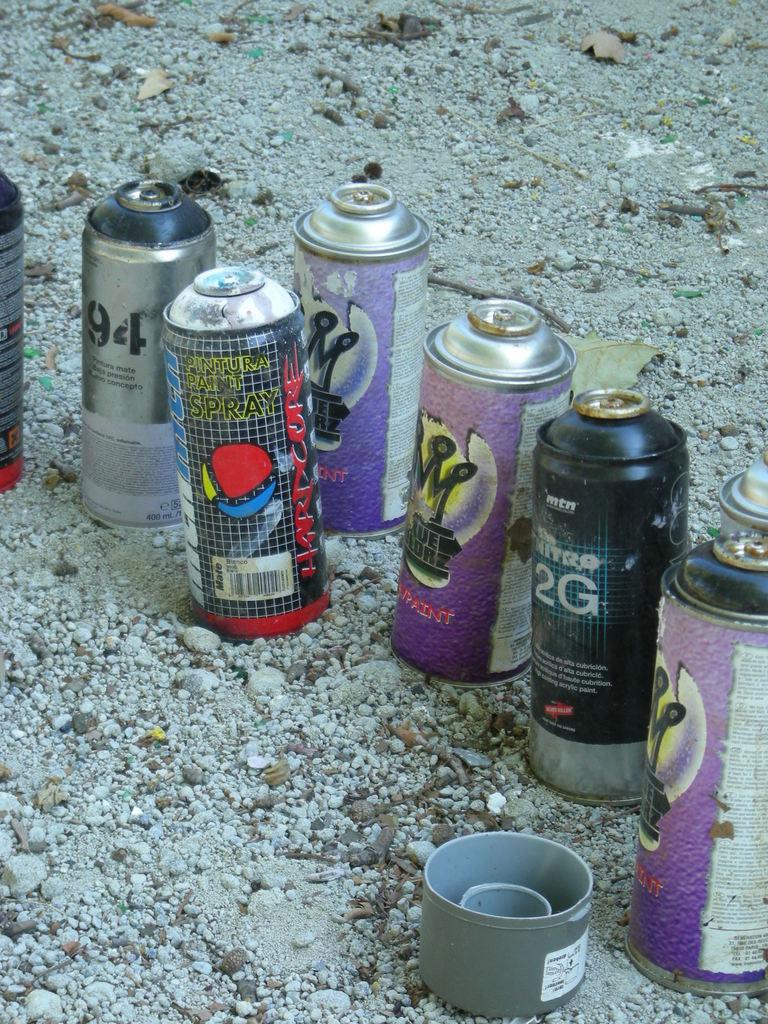What is in one of the bottles?
Provide a short and direct response. Spray paint. What number is on the black bottle?
Provide a short and direct response. 2. 